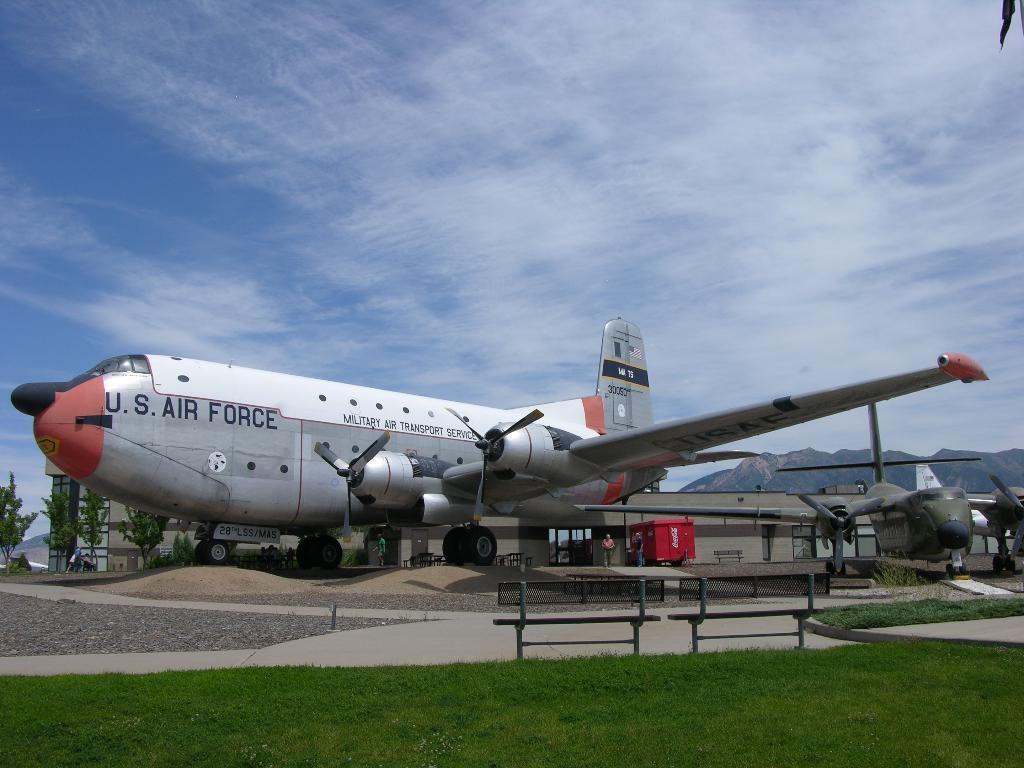Can you describe this image briefly? In this picture we can see a plane, which is on the road. Here we can see shed. On the top we can see sky and clouds. On the bottom we can see bench and grass. 